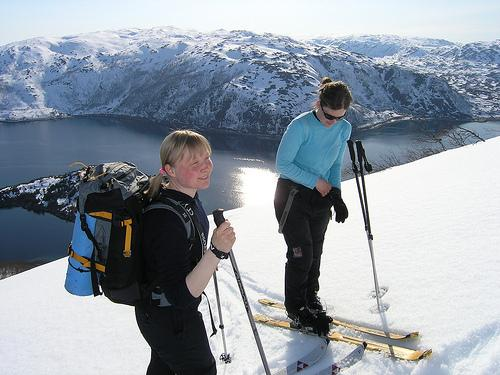How many people are skiing in the image? There are two women skiing in the image. What color is the backpack in the image and what kind of straps does it have? The backpack is blue and black with yellow straps. What is behind the women in the image? There is a lake of water and snowy mountains behind the women. Identify the main subject of this image. Two women on skis in a snowy landscape. What is the overall sentiment of the image? The image portrays an adventurous and exciting experience of skiing and snowboarding in a beautiful snowy landscape. What type of landscape is in the image? The image shows a snowy mountain landscape with a lake. Mention a unique feature of each woman in terms of their accessories or clothing. One woman has a red band in her hair and the other woman is wearing black eye glasses. Describe the weather condition as portrayed in the image. The sky is clear and blue indicating good weather conditions. What sport-related object is present in the image besides skis? There is a woman using a snowboard in the image. Mention three distinct objects or features related to the skiing activity in the image. Ski tracks in the snow, ski poles poked into the snow, and a pair of yellow skis. Can you spot the man skiing in the background? There is no mention of a man skiing in the image; only women are mentioned as skiing or on snowboards. Does the woman have a purple headband in her hair? No woman is mentioned to wear a purple headband, only a red band and a pink color band are mentioned. Do you see any trees on the snowy mountain? There are no mentions of trees on the mountain; only smooth snow, snowy rocky mountains, ski tracks, and tracks in the snow are discussed. Can you find any dogs accompanying the women in the image? There are no mentions of dogs or any other animals in the image; only people and skiing/snowboarding equipment are discussed. Is the woman wearing a green jacket in the image? There is no mention of a woman wearing a green jacket in the image, only a blue sweater and a black snow suit are mentioned. Is there a person riding a snowmobile in the image? There is no mention of any person riding a snowmobile in the image. Only people skiing and snowboarding are mentioned. 